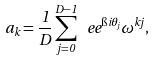<formula> <loc_0><loc_0><loc_500><loc_500>a _ { k } = \frac { 1 } { D } \sum _ { j = 0 } ^ { D - 1 } \ e e ^ { \i i \theta _ { j } } \omega ^ { k j } ,</formula> 